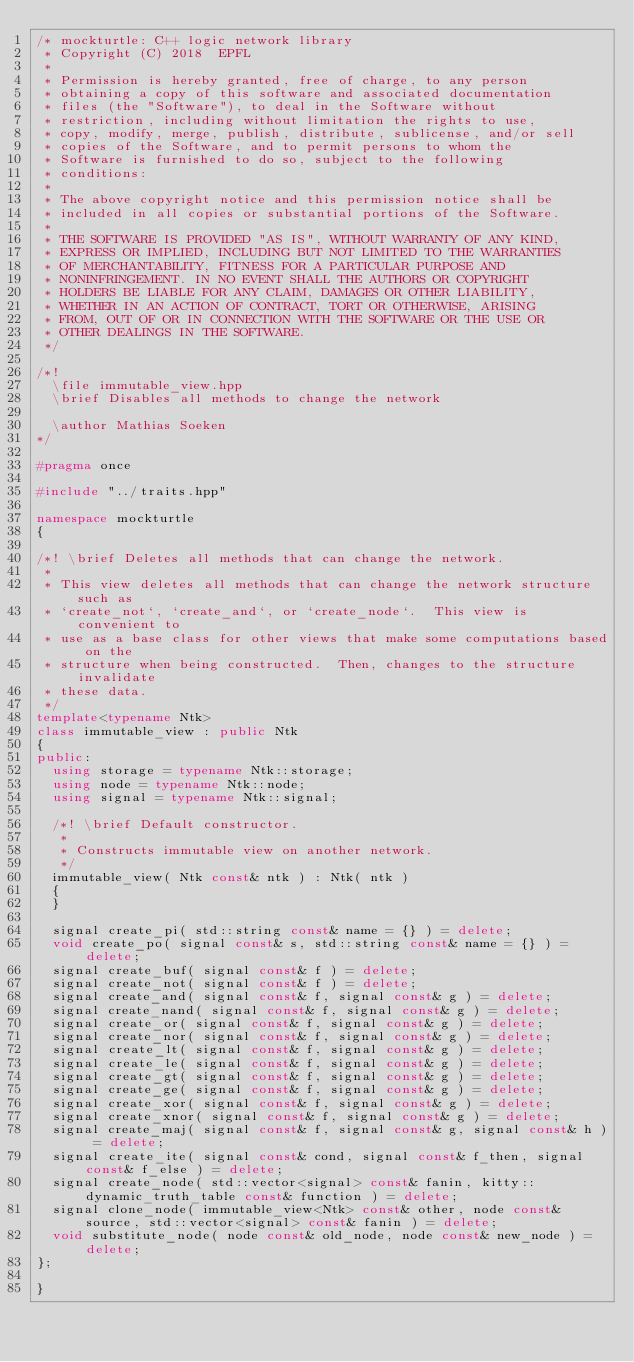<code> <loc_0><loc_0><loc_500><loc_500><_C++_>/* mockturtle: C++ logic network library
 * Copyright (C) 2018  EPFL
 *
 * Permission is hereby granted, free of charge, to any person
 * obtaining a copy of this software and associated documentation
 * files (the "Software"), to deal in the Software without
 * restriction, including without limitation the rights to use,
 * copy, modify, merge, publish, distribute, sublicense, and/or sell
 * copies of the Software, and to permit persons to whom the
 * Software is furnished to do so, subject to the following
 * conditions:
 *
 * The above copyright notice and this permission notice shall be
 * included in all copies or substantial portions of the Software.
 *
 * THE SOFTWARE IS PROVIDED "AS IS", WITHOUT WARRANTY OF ANY KIND,
 * EXPRESS OR IMPLIED, INCLUDING BUT NOT LIMITED TO THE WARRANTIES
 * OF MERCHANTABILITY, FITNESS FOR A PARTICULAR PURPOSE AND
 * NONINFRINGEMENT. IN NO EVENT SHALL THE AUTHORS OR COPYRIGHT
 * HOLDERS BE LIABLE FOR ANY CLAIM, DAMAGES OR OTHER LIABILITY,
 * WHETHER IN AN ACTION OF CONTRACT, TORT OR OTHERWISE, ARISING
 * FROM, OUT OF OR IN CONNECTION WITH THE SOFTWARE OR THE USE OR
 * OTHER DEALINGS IN THE SOFTWARE.
 */

/*!
  \file immutable_view.hpp
  \brief Disables all methods to change the network

  \author Mathias Soeken
*/

#pragma once

#include "../traits.hpp"

namespace mockturtle
{

/*! \brief Deletes all methods that can change the network.
 *
 * This view deletes all methods that can change the network structure such as
 * `create_not`, `create_and`, or `create_node`.  This view is convenient to
 * use as a base class for other views that make some computations based on the
 * structure when being constructed.  Then, changes to the structure invalidate
 * these data.
 */
template<typename Ntk>
class immutable_view : public Ntk
{
public:
  using storage = typename Ntk::storage;
  using node = typename Ntk::node;
  using signal = typename Ntk::signal;

  /*! \brief Default constructor.
   *
   * Constructs immutable view on another network.
   */
  immutable_view( Ntk const& ntk ) : Ntk( ntk )
  {
  }

  signal create_pi( std::string const& name = {} ) = delete;
  void create_po( signal const& s, std::string const& name = {} ) = delete;
  signal create_buf( signal const& f ) = delete;
  signal create_not( signal const& f ) = delete;
  signal create_and( signal const& f, signal const& g ) = delete;
  signal create_nand( signal const& f, signal const& g ) = delete;
  signal create_or( signal const& f, signal const& g ) = delete;
  signal create_nor( signal const& f, signal const& g ) = delete;
  signal create_lt( signal const& f, signal const& g ) = delete;
  signal create_le( signal const& f, signal const& g ) = delete;
  signal create_gt( signal const& f, signal const& g ) = delete;
  signal create_ge( signal const& f, signal const& g ) = delete;
  signal create_xor( signal const& f, signal const& g ) = delete;
  signal create_xnor( signal const& f, signal const& g ) = delete;
  signal create_maj( signal const& f, signal const& g, signal const& h ) = delete;
  signal create_ite( signal const& cond, signal const& f_then, signal const& f_else ) = delete;
  signal create_node( std::vector<signal> const& fanin, kitty::dynamic_truth_table const& function ) = delete;
  signal clone_node( immutable_view<Ntk> const& other, node const& source, std::vector<signal> const& fanin ) = delete;
  void substitute_node( node const& old_node, node const& new_node ) = delete;
};

}
</code> 